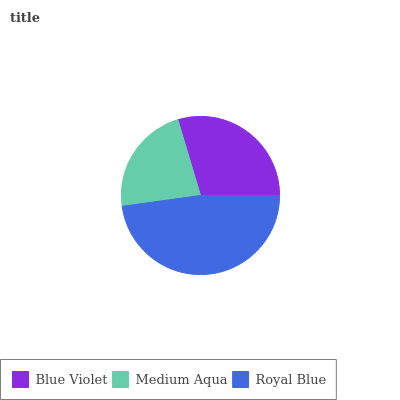Is Medium Aqua the minimum?
Answer yes or no. Yes. Is Royal Blue the maximum?
Answer yes or no. Yes. Is Royal Blue the minimum?
Answer yes or no. No. Is Medium Aqua the maximum?
Answer yes or no. No. Is Royal Blue greater than Medium Aqua?
Answer yes or no. Yes. Is Medium Aqua less than Royal Blue?
Answer yes or no. Yes. Is Medium Aqua greater than Royal Blue?
Answer yes or no. No. Is Royal Blue less than Medium Aqua?
Answer yes or no. No. Is Blue Violet the high median?
Answer yes or no. Yes. Is Blue Violet the low median?
Answer yes or no. Yes. Is Royal Blue the high median?
Answer yes or no. No. Is Medium Aqua the low median?
Answer yes or no. No. 